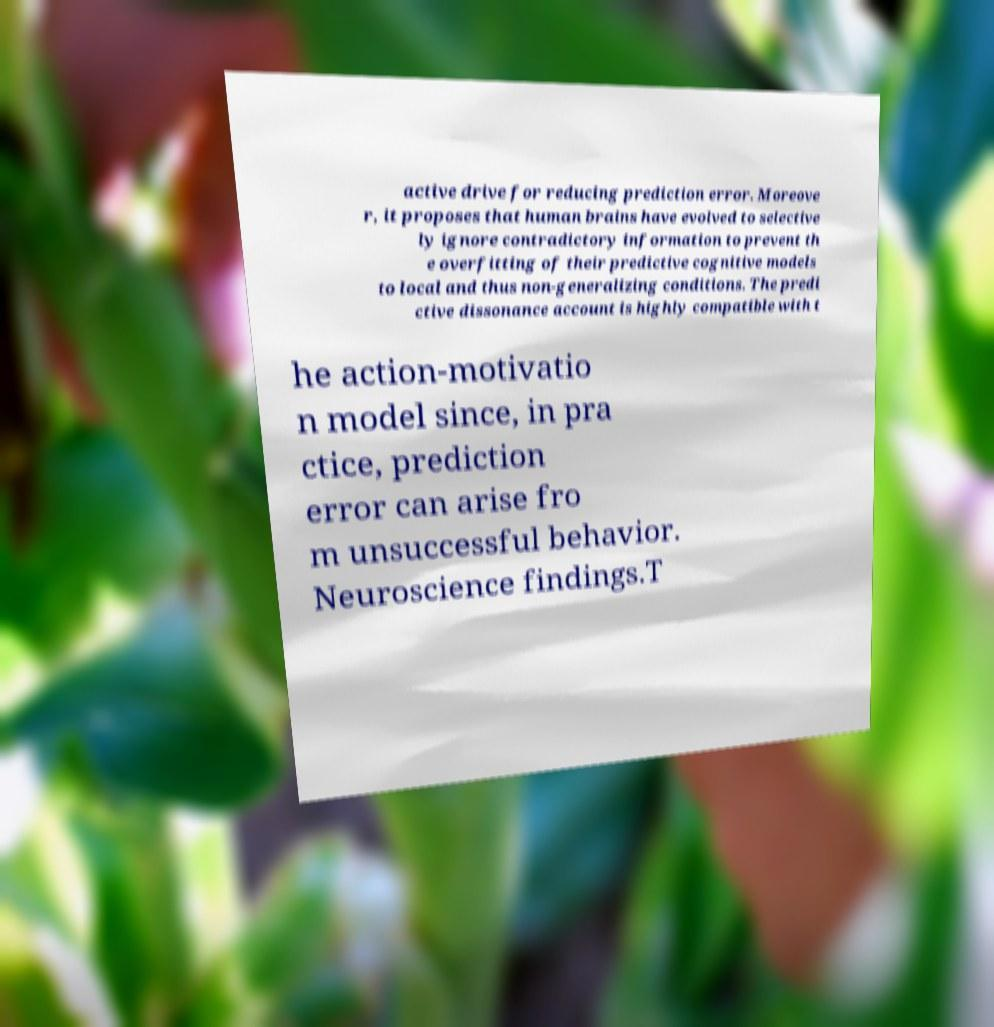Please identify and transcribe the text found in this image. active drive for reducing prediction error. Moreove r, it proposes that human brains have evolved to selective ly ignore contradictory information to prevent th e overfitting of their predictive cognitive models to local and thus non-generalizing conditions. The predi ctive dissonance account is highly compatible with t he action-motivatio n model since, in pra ctice, prediction error can arise fro m unsuccessful behavior. Neuroscience findings.T 